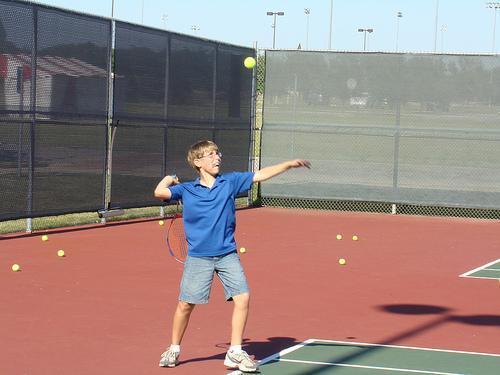How many people are in the photo?
Give a very brief answer. 1. 